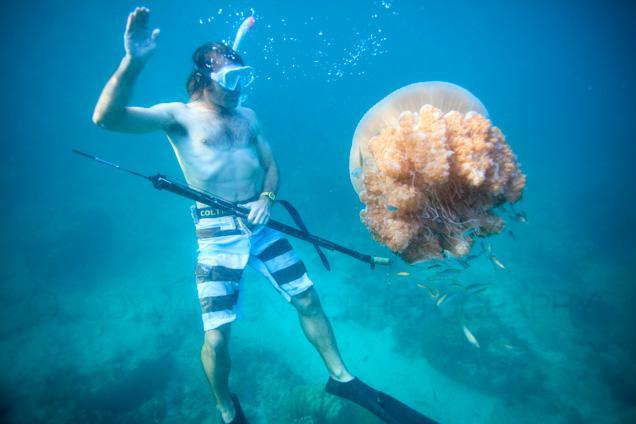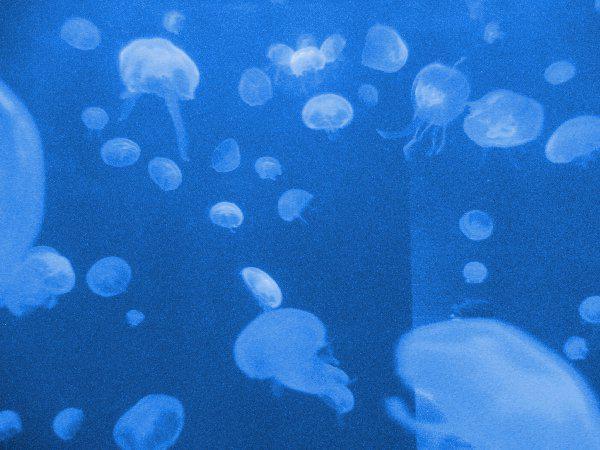The first image is the image on the left, the second image is the image on the right. For the images shown, is this caption "All the jellyfish in one image are purplish-pink in color." true? Answer yes or no. No. 